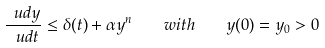Convert formula to latex. <formula><loc_0><loc_0><loc_500><loc_500>\frac { \ u d y } { \ u d t } \leq \delta ( t ) + \alpha y ^ { n } \quad w i t h \quad y ( 0 ) = y _ { 0 } > 0</formula> 